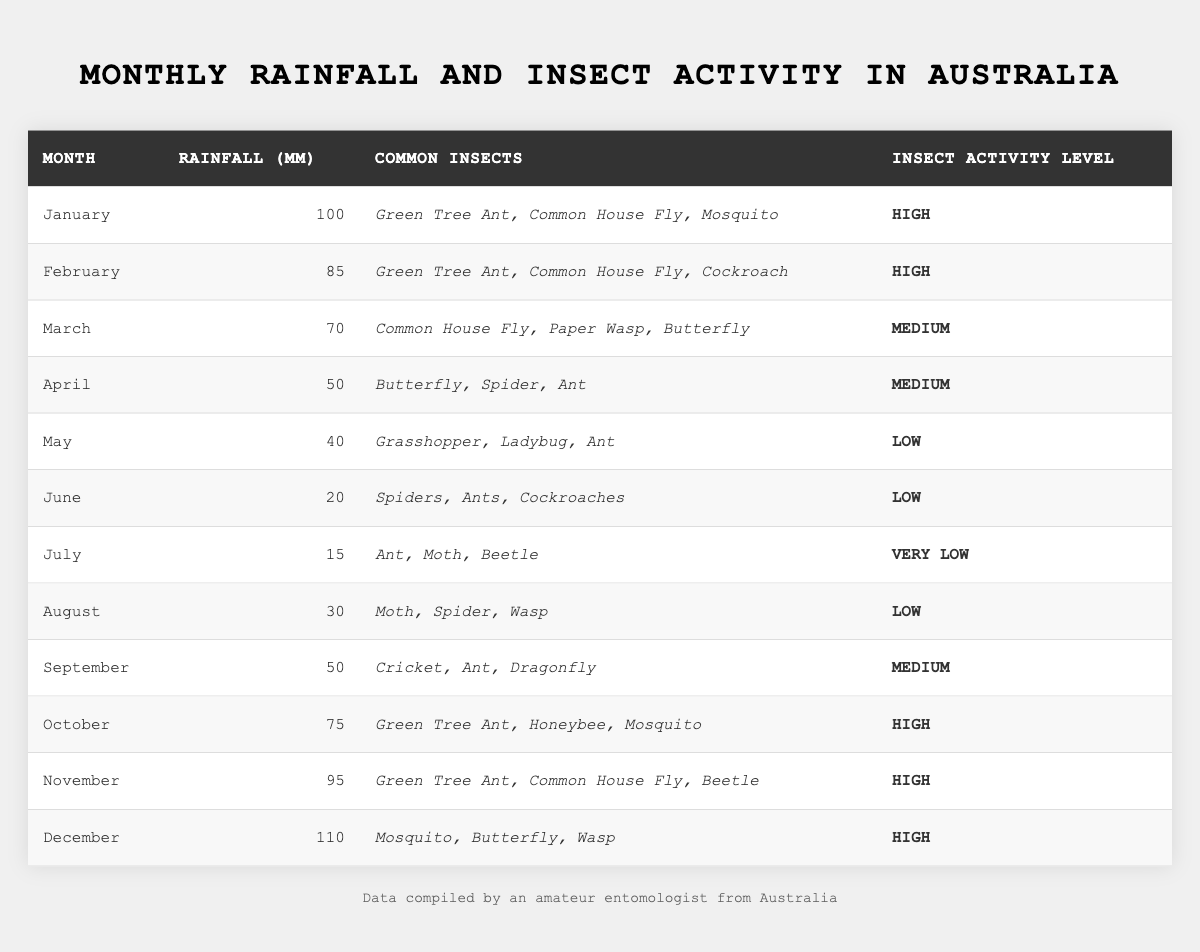What is the total rainfall in millimeters for the month of January? According to the table, the rainfall for January is listed as 100 mm.
Answer: 100 mm Which month has the highest insect activity level? The table indicates that the insect activity level is "High" in January, February, October, November, and December. However, we are looking for the month with the highest recorded rainfall among these months, which is December with 110 mm.
Answer: December How many different types of insects are commonly found in April? The table shows that in April, three types of insects are listed: Butterfly, Spider, and Ant.
Answer: 3 What is the average monthly rainfall for the months with low insect activity? The months with low insect activity are May (40 mm), June (20 mm), July (15 mm), and August (30 mm). Their total is 40 + 20 + 15 + 30 = 105 mm. To find the average, divide by the number of months (4): 105 / 4 = 26.25 mm.
Answer: 26.25 mm In which month do we see a transition from medium to low insect activity? Comparing the insect activity levels, April shows a medium activity level and May shows a low activity level, indicating that the transition occurs from April to May.
Answer: May Are there common insects in the months that experience high rainfall and high insect activity levels? Yes, January (100 mm) has Green Tree Ant, Common House Fly, and Mosquito. February (85 mm) has Green Tree Ant, Common House Fly, and Cockroach. October (75 mm) has Green Tree Ant, Honeybee, and Mosquito. November (95 mm) includes Green Tree Ant, Common House Fly, and Beetle. Thus, Green Tree Ant and Common House Fly appear in January, February, and November.
Answer: Yes How does the rainfall in September compare to that in June? September has 50 mm of rainfall while June has 20 mm. To compare, subtract June's rainfall from September's: 50 - 20 = 30 mm. Therefore, September has 30 mm more rainfall than June.
Answer: 30 mm more During which months is the Insect Activity Level classified as ‘Very Low’? Based on the table, only July is designated as having a Very Low insect activity level.
Answer: July What is the total rainfall during the months categorized with medium insect activity? The months with medium insect activity are March (70 mm), April (50 mm), and September (50 mm). Adding these together gives: 70 + 50 + 50 = 170 mm.
Answer: 170 mm Which months have a common presence of Mosquito? Mosquitos are present in January, October, and December according to the table.
Answer: January, October, December Is the insect activity level related to the amount of rainfall? Analyzing the table, it shows that higher levels of rainfall (January, February, October, November, and December) coincide with high insect activity levels. Hence, it suggests a relationship.
Answer: Yes 